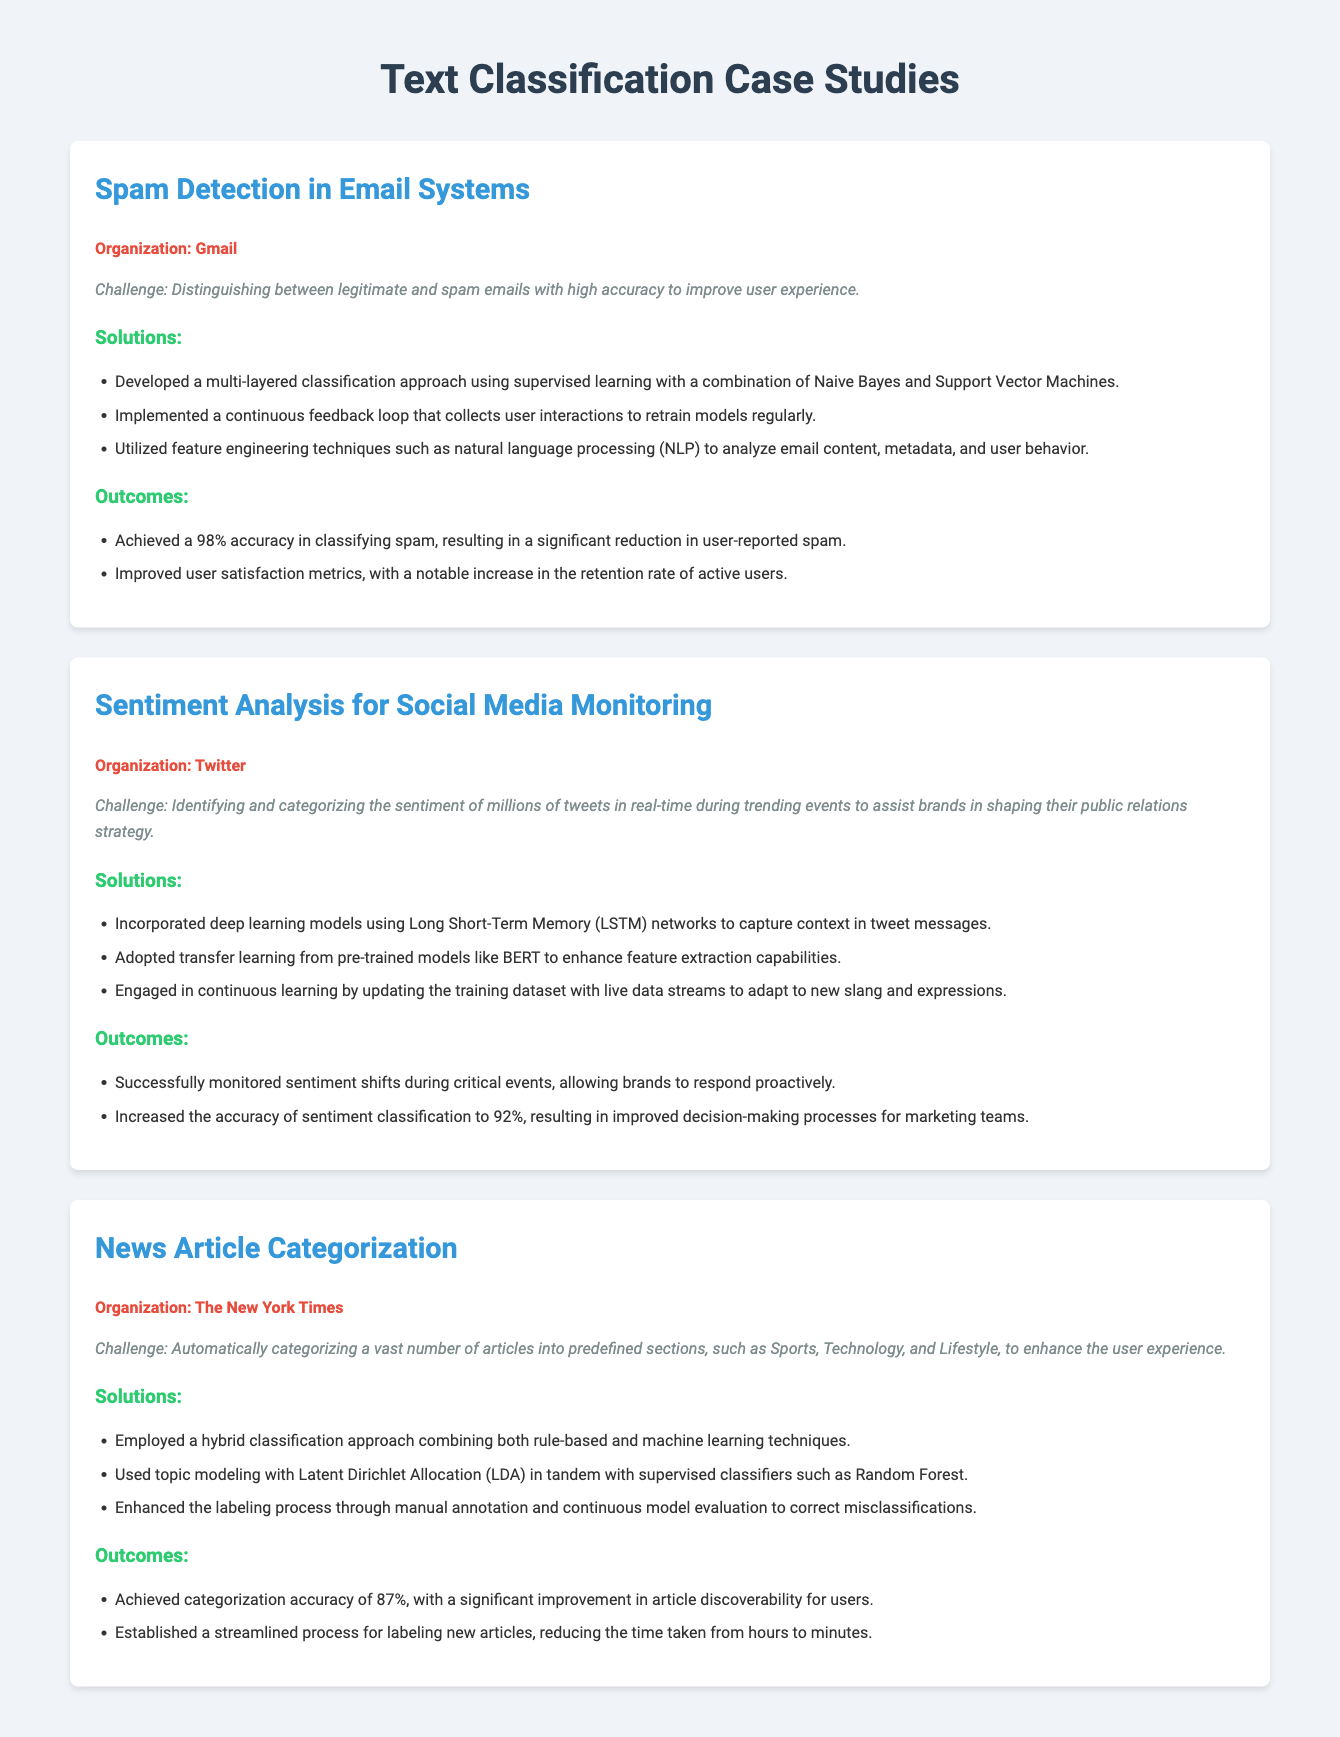What is the organization for spam detection? The document states that the organization for the spam detection case study is Gmail.
Answer: Gmail What classification technique did Gmail use for spam detection? According to the document, Gmail developed a multi-layered classification approach using supervised learning with a combination of Naive Bayes and Support Vector Machines.
Answer: Naive Bayes and Support Vector Machines What was the accuracy achieved in classifying spam by Gmail? The document mentions that Gmail achieved a 98% accuracy in classifying spam.
Answer: 98% What type of model did Twitter use for sentiment analysis? The document indicates that Twitter incorporated deep learning models using Long Short-Term Memory (LSTM) networks.
Answer: Long Short-Term Memory (LSTM) What was the categorization accuracy achieved by The New York Times? The document specifies that The New York Times achieved categorization accuracy of 87%.
Answer: 87% Which techniques were combined for news article categorization? The document states that a hybrid classification approach combining both rule-based and machine learning techniques was employed.
Answer: Rule-based and machine learning techniques How did Twitter enhance feature extraction capabilities? The document explains that Twitter adopted transfer learning from pre-trained models like BERT to enhance feature extraction capabilities.
Answer: BERT What was a notable outcome of the spam detection project? According to the document, a notable outcome was a significant reduction in user-reported spam.
Answer: Significant reduction in user-reported spam 